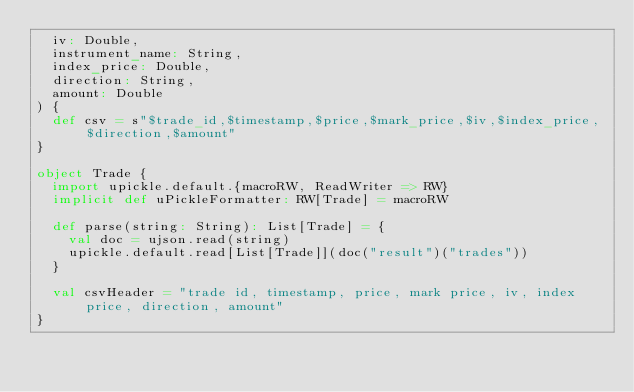Convert code to text. <code><loc_0><loc_0><loc_500><loc_500><_Scala_>  iv: Double,
  instrument_name: String,
  index_price: Double,
  direction: String,
  amount: Double
) {
  def csv = s"$trade_id,$timestamp,$price,$mark_price,$iv,$index_price,$direction,$amount"
}

object Trade {
  import upickle.default.{macroRW, ReadWriter => RW}
  implicit def uPickleFormatter: RW[Trade] = macroRW

  def parse(string: String): List[Trade] = {
    val doc = ujson.read(string)
    upickle.default.read[List[Trade]](doc("result")("trades"))
  }

  val csvHeader = "trade id, timestamp, price, mark price, iv, index price, direction, amount"
}</code> 